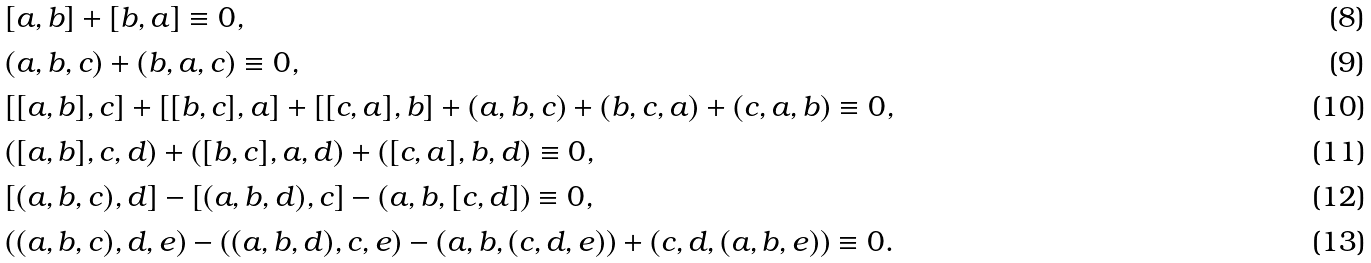<formula> <loc_0><loc_0><loc_500><loc_500>& [ a , b ] + [ b , a ] \equiv 0 , \\ & ( a , b , c ) + ( b , a , c ) \equiv 0 , \\ & [ [ a , b ] , c ] + [ [ b , c ] , a ] + [ [ c , a ] , b ] + ( a , b , c ) + ( b , c , a ) + ( c , a , b ) \equiv 0 , \\ & ( [ a , b ] , c , d ) + ( [ b , c ] , a , d ) + ( [ c , a ] , b , d ) \equiv 0 , \\ & [ ( a , b , c ) , d ] - [ ( a , b , d ) , c ] - ( a , b , [ c , d ] ) \equiv 0 , \\ & ( ( a , b , c ) , d , e ) - ( ( a , b , d ) , c , e ) - ( a , b , ( c , d , e ) ) + ( c , d , ( a , b , e ) ) \equiv 0 .</formula> 